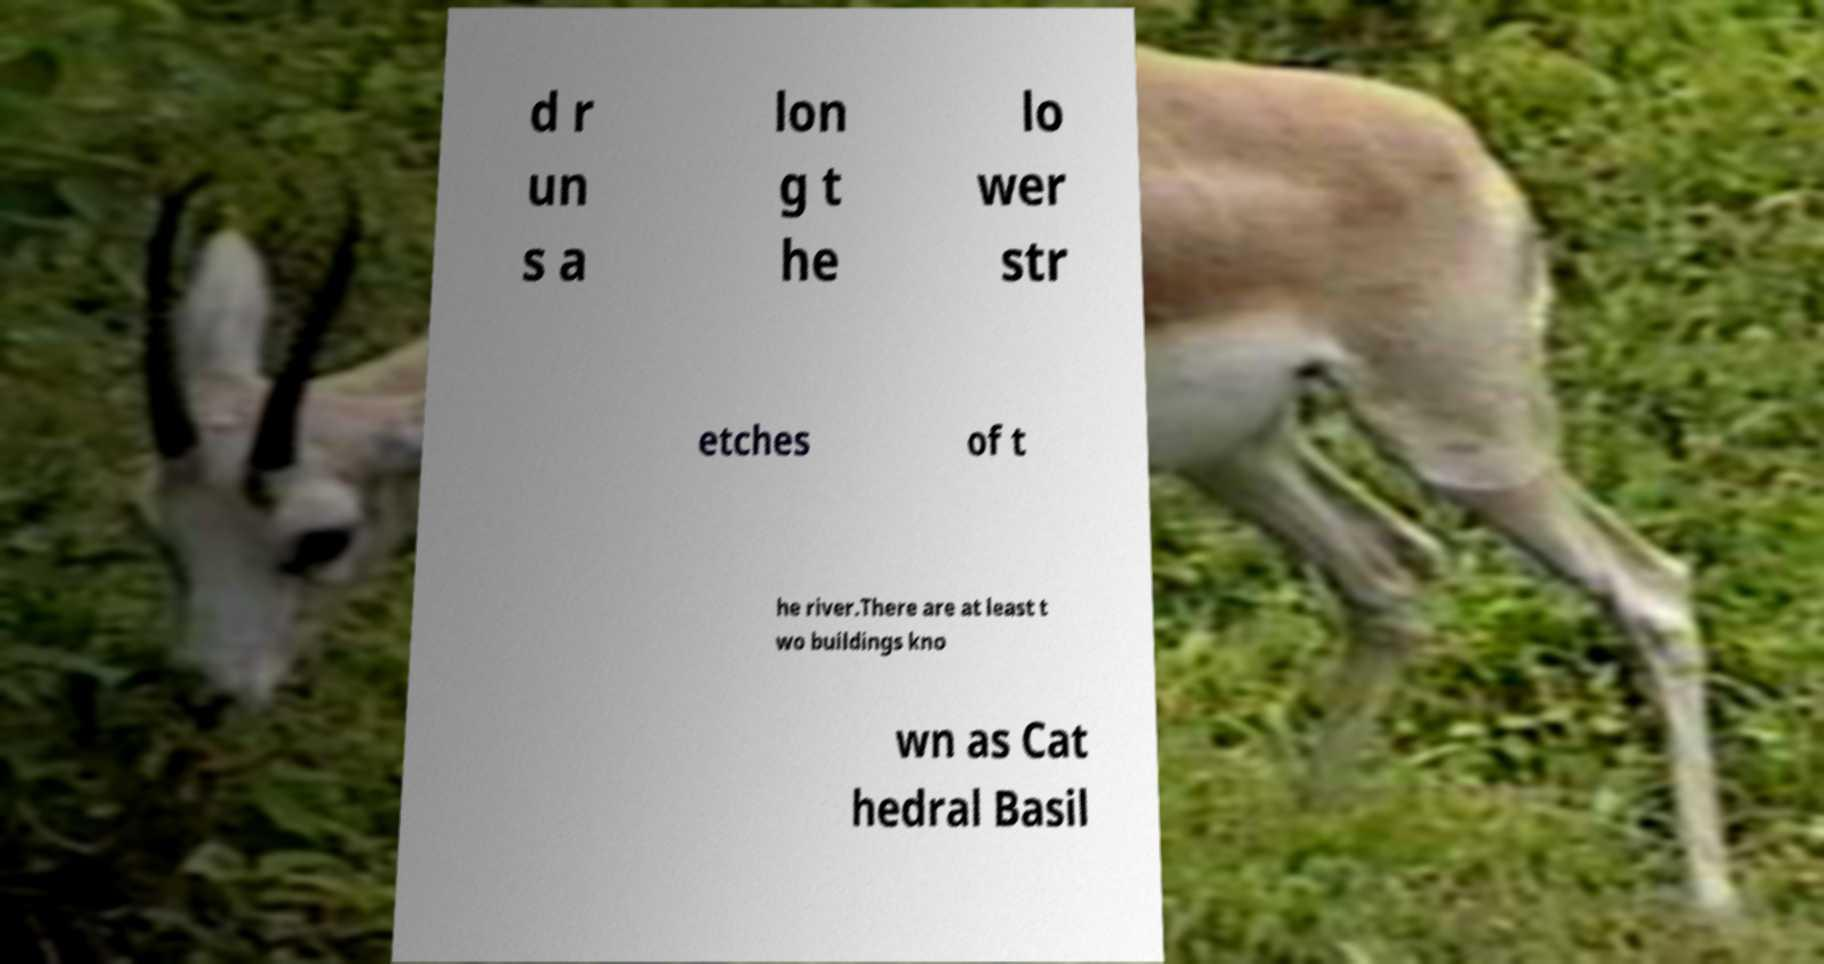There's text embedded in this image that I need extracted. Can you transcribe it verbatim? d r un s a lon g t he lo wer str etches of t he river.There are at least t wo buildings kno wn as Cat hedral Basil 